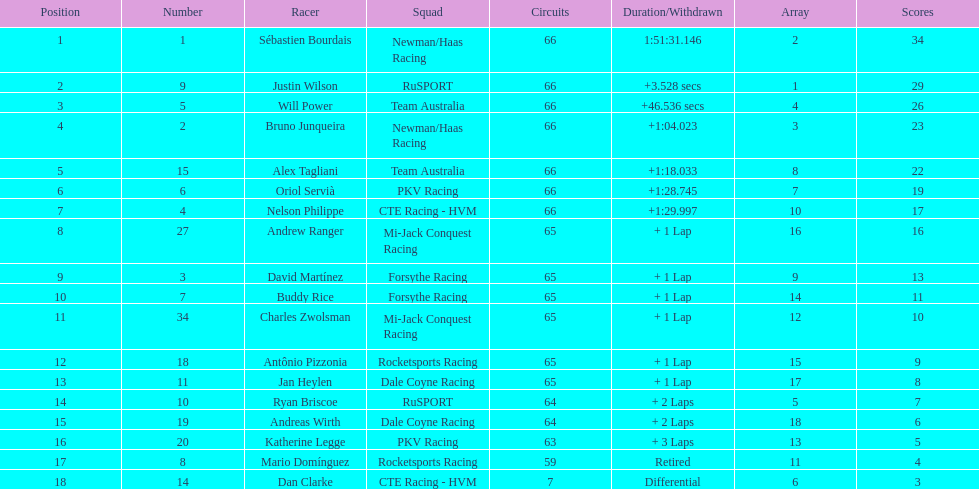Who finished directly after the driver who finished in 1:28.745? Nelson Philippe. 